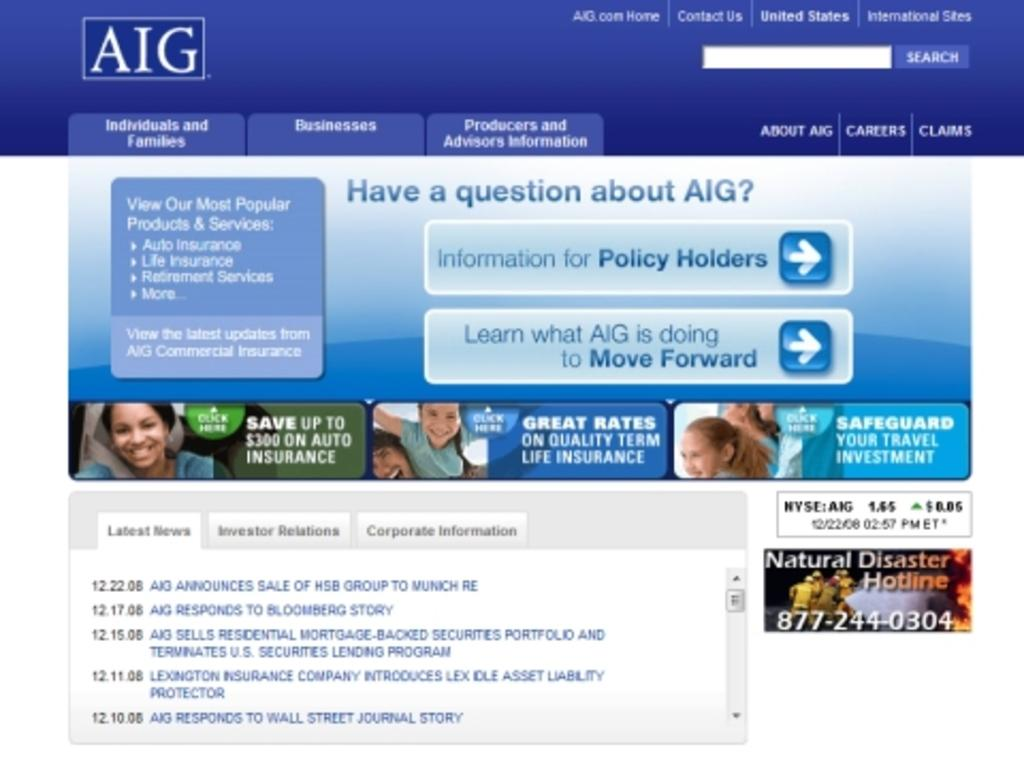What can be found on the page in the image? There are symbols and text on the page. What else can be seen on the page? There are people smiling on the page. What type of copper material is used to create the airplane in the image? There is no airplane present in the image, and therefore no copper material can be observed. Are the people wearing masks in the image? The provided facts do not mention anything about masks, so we cannot determine if the people are wearing masks or not. 